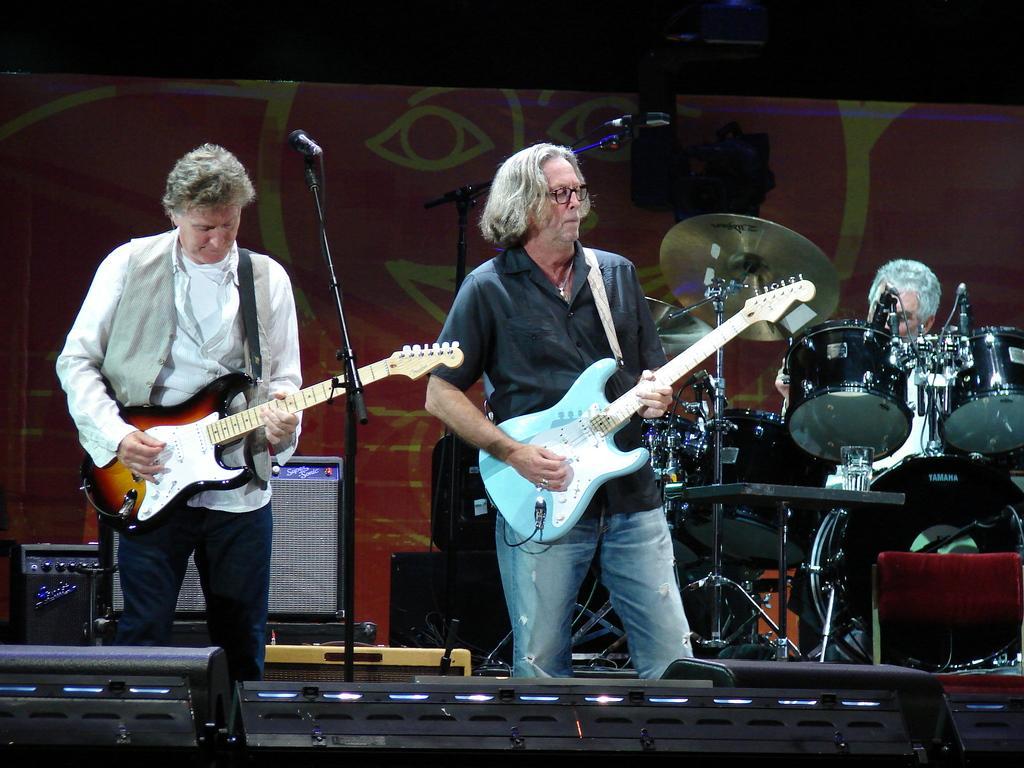Describe this image in one or two sentences. In the image there are two people they are playing guitar. There is a mic placed before them. In the background there is a band and board. 